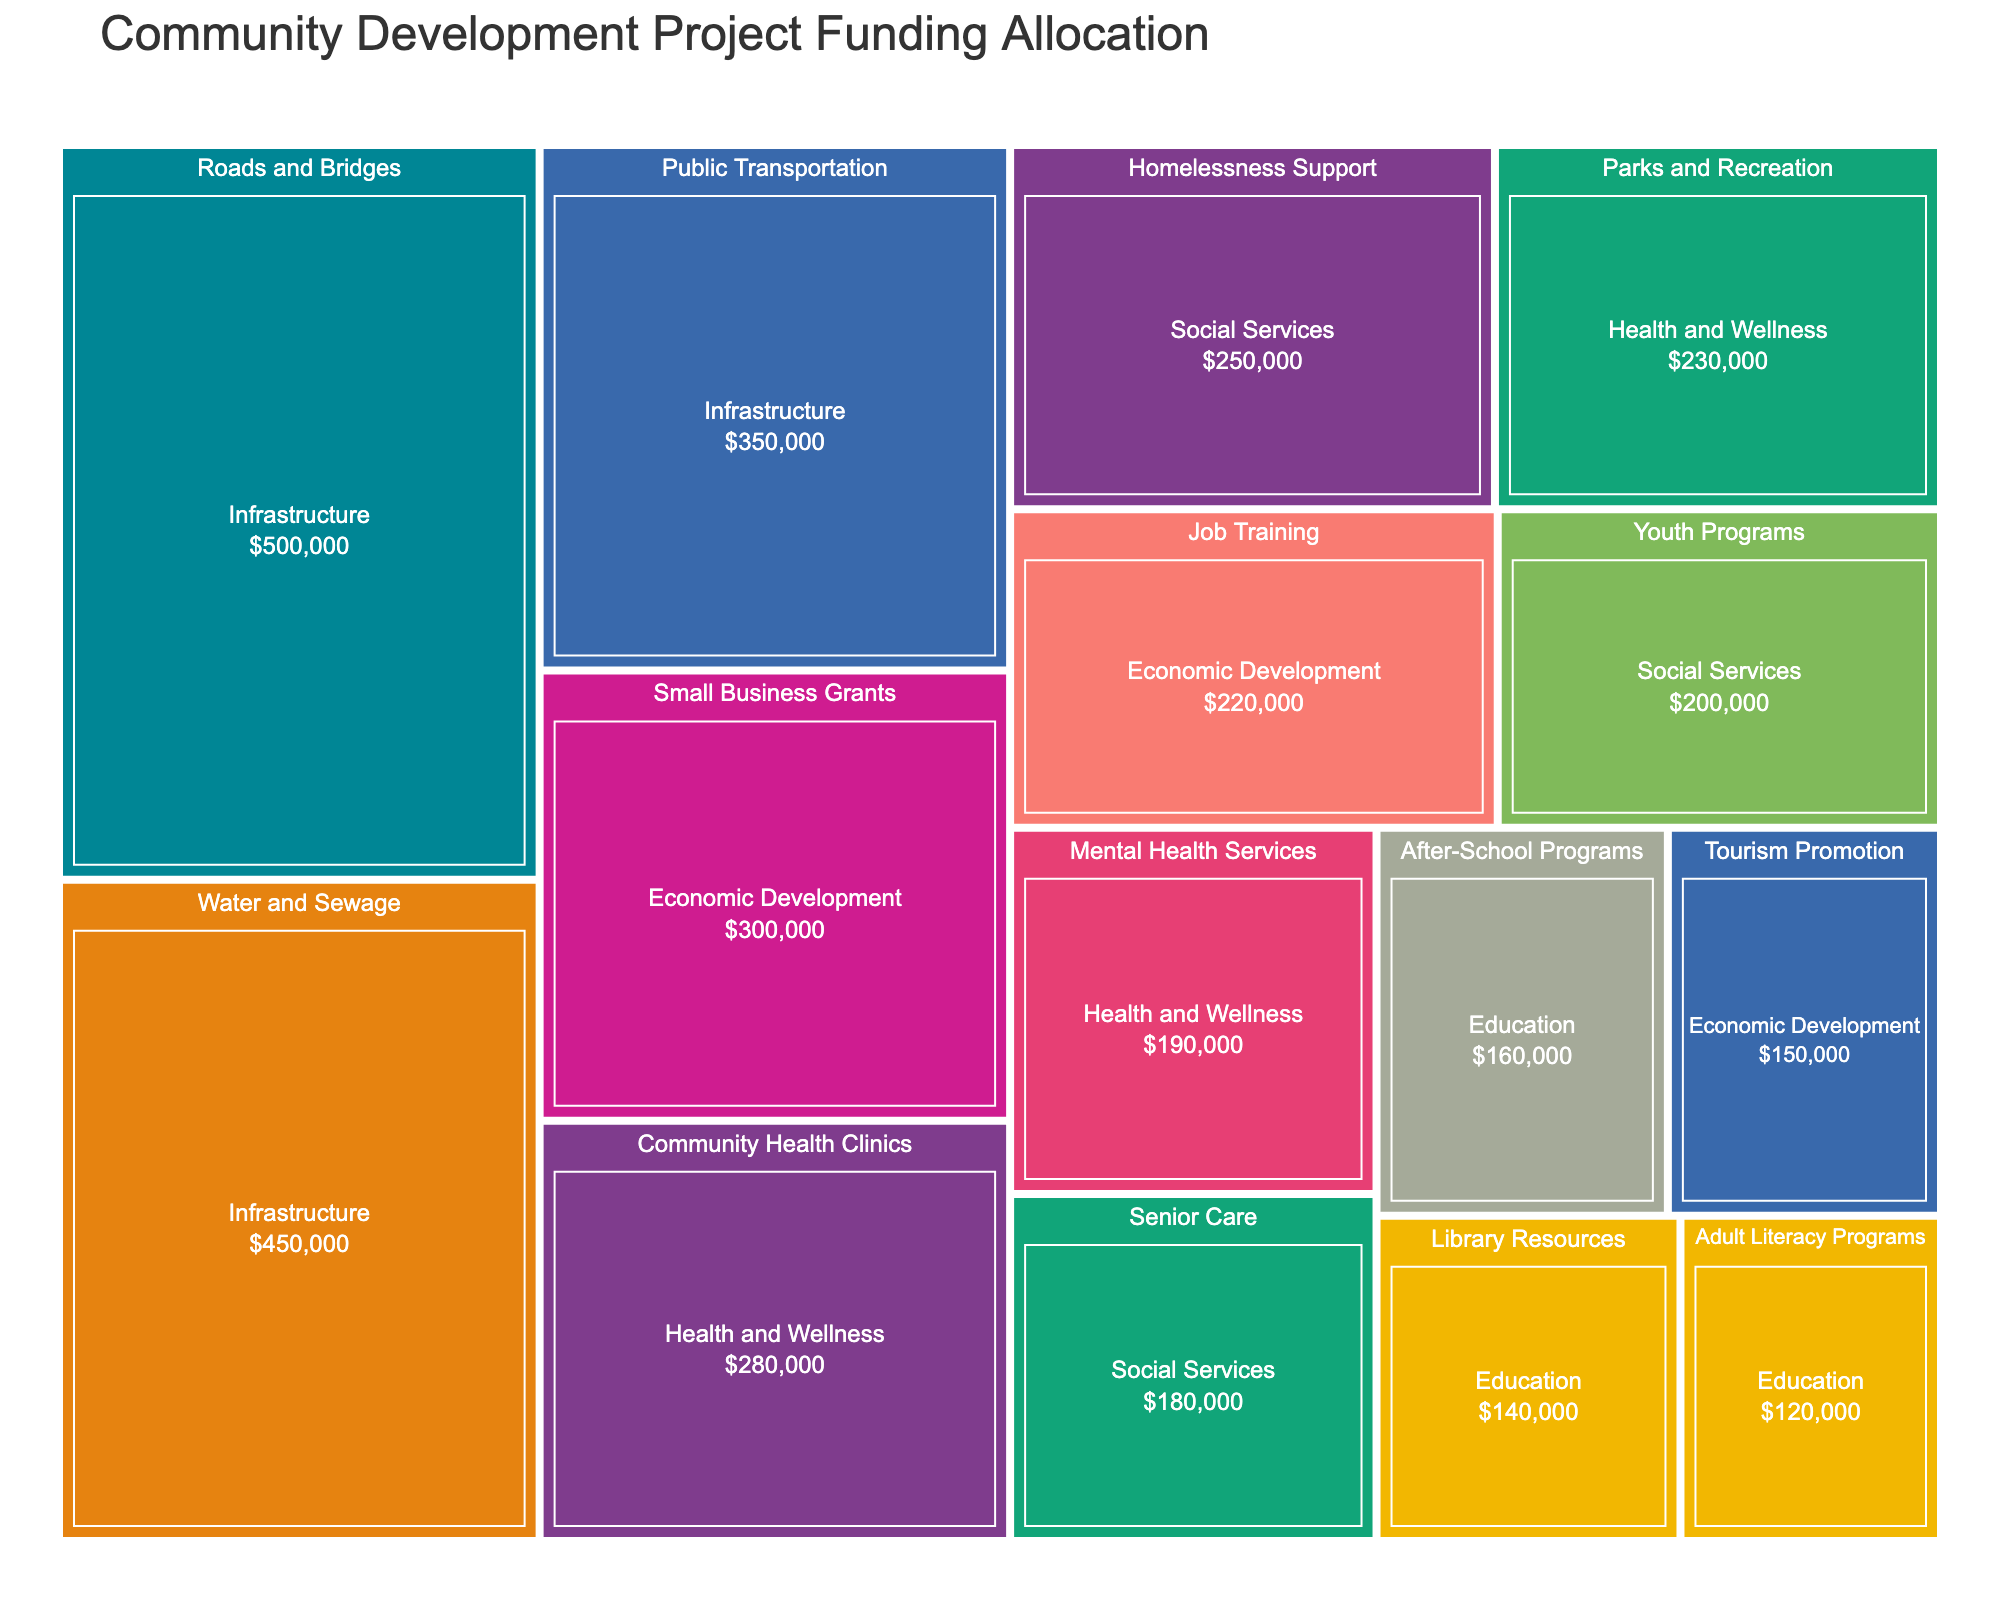What is the title of the Treemap? The title is usually displayed prominently at the top of the Treemap. In this case, the title is mentioned in the code as 'Community Development Project Funding Allocation'.
Answer: Community Development Project Funding Allocation Which project received the highest amount of funding within the 'Infrastructure' category? The components within each category are displayed as rectangles in the Treemap. The size of each rectangle reflects the amount of funding. By identifying the largest rectangle within the 'Infrastructure' category, we see that 'Roads and Bridges' received $500,000.
Answer: Roads and Bridges How much total funding was allocated to the 'Economic Development' category? To find the total funding for 'Economic Development', sum the funding of all projects within that category: Small Business Grants ($300,000) + Job Training ($220,000) + Tourism Promotion ($150,000).
Answer: $670,000 Which category has the least amount of funding? By observing the relative sizes of the main category rectangles in the Treemap, the smallest rectangle represents 'Education'.
Answer: Education Compare the funding for 'Community Health Clinics' and 'Parks and Recreation'. Which one received more funding and by how much? Check and compare the size and the value displayed within the rectangles for both 'Community Health Clinics' ($280,000) and 'Parks and Recreation' ($230,000). Community Health Clinics received more funding by $50,000.
Answer: Community Health Clinics, $50,000 What is the total funding allocated to 'Social Services'? Add the funding amounts for the projects under 'Social Services': Youth Programs ($200,000) + Senior Care ($180,000) + Homelessness Support ($250,000).
Answer: $630,000 Which project received the lowest amount of funding in the 'Health and Wellness' category? Observe the sizes and values of the rectangles within 'Health and Wellness'. The smallest rectangle is for 'Mental Health Services' with $190,000.
Answer: Mental Health Services How does the funding for 'After-School Programs' compare to 'Library Resources'? Look at both rectangles under 'Education'. 'After-School Programs' received $160,000 while 'Library Resources' received $140,000. 'After-School Programs' received $20,000 more.
Answer: After-School Programs, $20,000 What's the average funding allocated to projects within the 'Infrastructure' category? First, find the total funding for 'Infrastructure' projects: Roads and Bridges ($500,000) + Public Transportation ($350,000) + Water and Sewage ($450,000). The total is $1,300,000. There are 3 projects, so the average is $1,300,000 / 3.
Answer: $433,333.33 